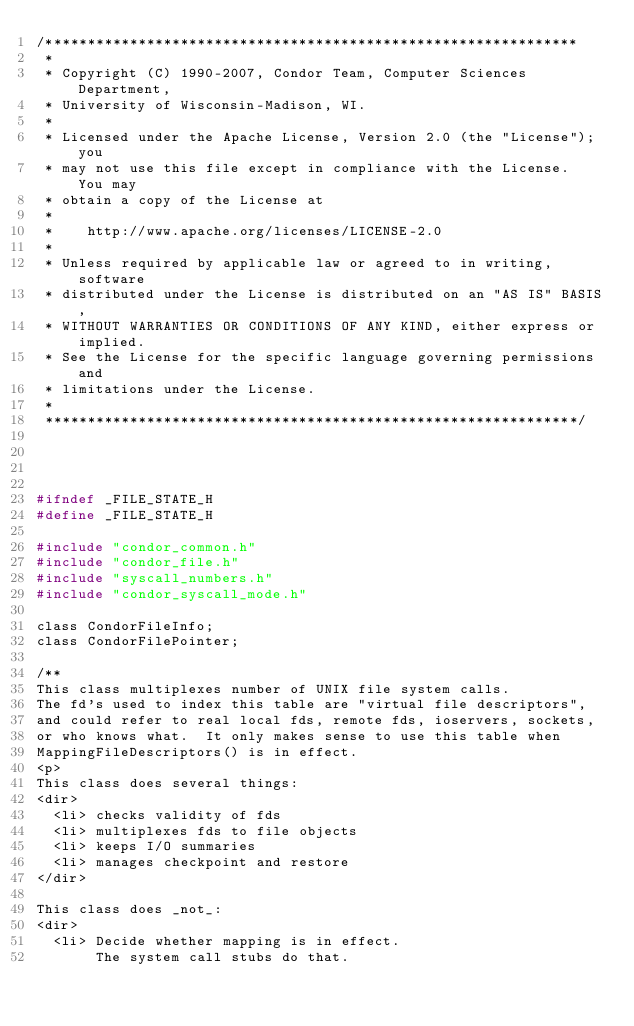Convert code to text. <code><loc_0><loc_0><loc_500><loc_500><_C_>/***************************************************************
 *
 * Copyright (C) 1990-2007, Condor Team, Computer Sciences Department,
 * University of Wisconsin-Madison, WI.
 * 
 * Licensed under the Apache License, Version 2.0 (the "License"); you
 * may not use this file except in compliance with the License.  You may
 * obtain a copy of the License at
 * 
 *    http://www.apache.org/licenses/LICENSE-2.0
 * 
 * Unless required by applicable law or agreed to in writing, software
 * distributed under the License is distributed on an "AS IS" BASIS,
 * WITHOUT WARRANTIES OR CONDITIONS OF ANY KIND, either express or implied.
 * See the License for the specific language governing permissions and
 * limitations under the License.
 *
 ***************************************************************/


 

#ifndef _FILE_STATE_H
#define _FILE_STATE_H

#include "condor_common.h"
#include "condor_file.h"
#include "syscall_numbers.h"
#include "condor_syscall_mode.h"

class CondorFileInfo;
class CondorFilePointer;

/**
This class multiplexes number of UNIX file system calls.
The fd's used to index this table are "virtual file descriptors",
and could refer to real local fds, remote fds, ioservers, sockets,
or who knows what.  It only makes sense to use this table when
MappingFileDescriptors() is in effect.
<p>
This class does several things:
<dir> 
	<li> checks validity of fds  
	<li> multiplexes fds to file objects
	<li> keeps I/O summaries
	<li> manages checkpoint and restore
</dir>

This class does _not_:
<dir>
	<li> Decide whether mapping is in effect.
	     The system call stubs do that.</code> 